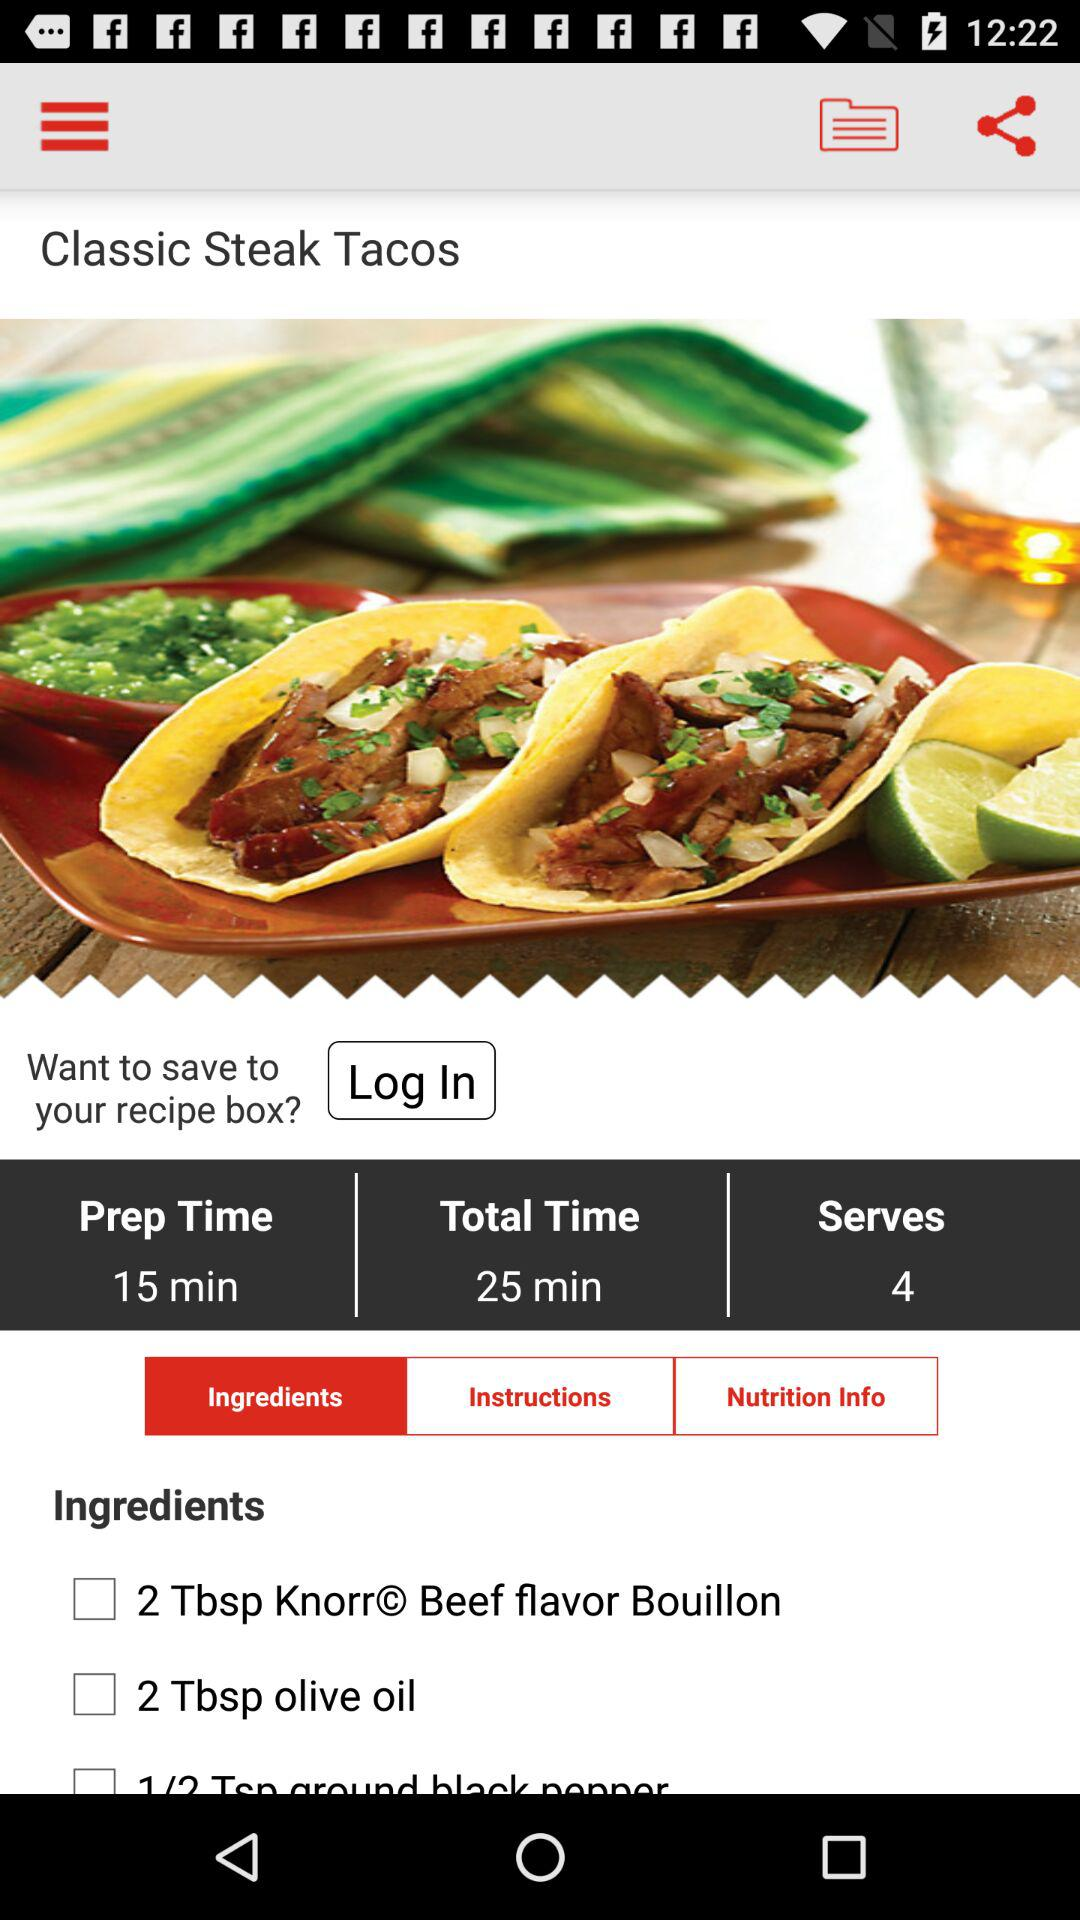How many more minutes is the total time than the prep time?
Answer the question using a single word or phrase. 10 